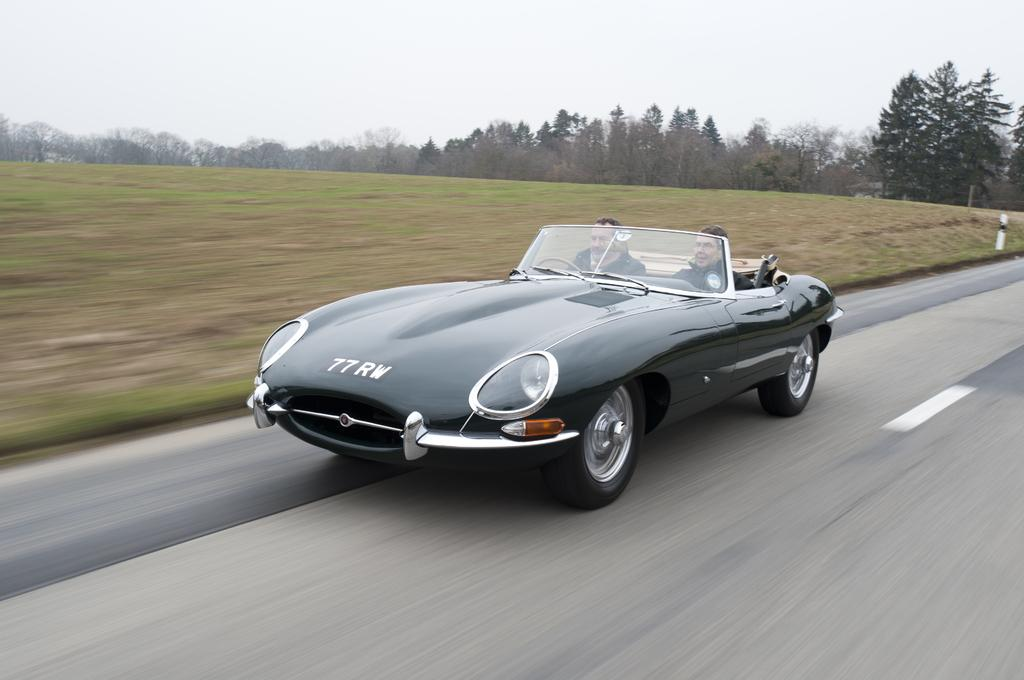Where was the image taken? The image was clicked outside. What can be seen at the top of the image? There are trees and sky visible at the top of the image. What is the main subject in the middle of the image? There is a car in the middle of the image. What is the color of the car? The car is black in color. How many people are inside the car? There are two persons sitting in the car. What type of ornament is hanging from the rearview mirror of the car? There is no information about an ornament hanging from the rearview mirror in the image. 